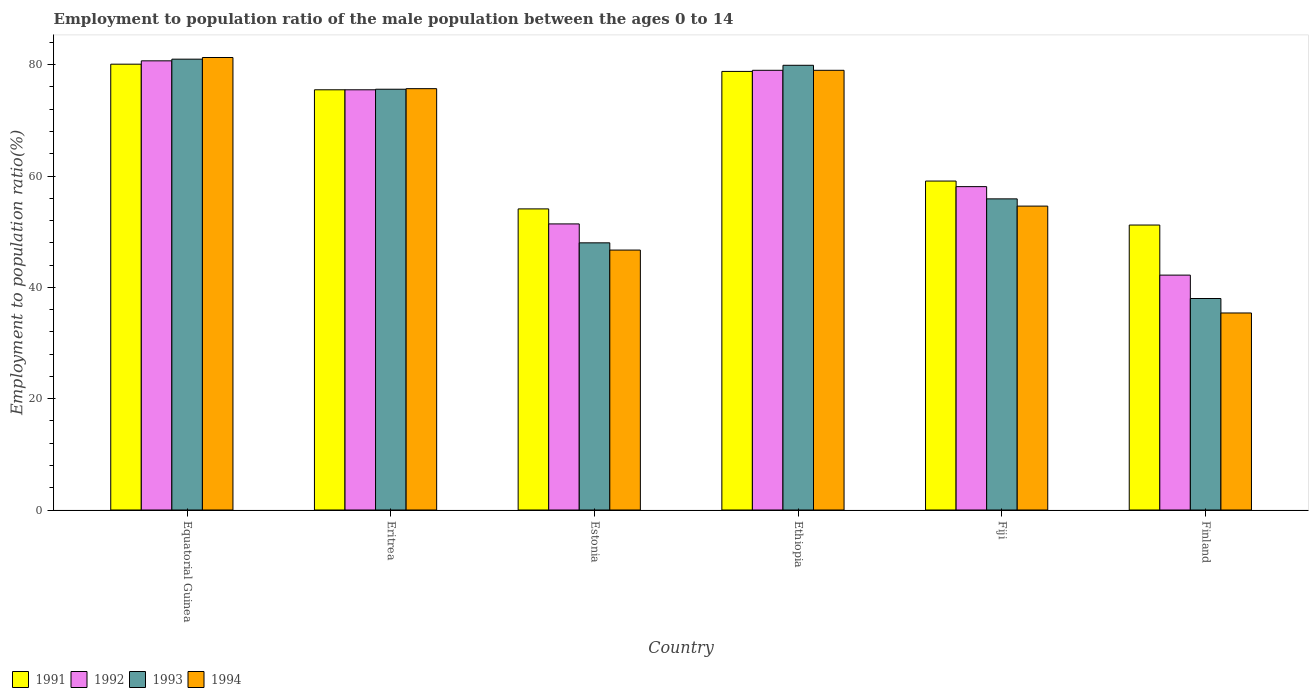How many different coloured bars are there?
Keep it short and to the point. 4. How many groups of bars are there?
Your answer should be compact. 6. Are the number of bars on each tick of the X-axis equal?
Offer a terse response. Yes. How many bars are there on the 1st tick from the left?
Provide a short and direct response. 4. What is the label of the 3rd group of bars from the left?
Keep it short and to the point. Estonia. What is the employment to population ratio in 1991 in Ethiopia?
Keep it short and to the point. 78.8. Across all countries, what is the maximum employment to population ratio in 1992?
Make the answer very short. 80.7. Across all countries, what is the minimum employment to population ratio in 1992?
Offer a very short reply. 42.2. In which country was the employment to population ratio in 1994 maximum?
Keep it short and to the point. Equatorial Guinea. In which country was the employment to population ratio in 1994 minimum?
Offer a very short reply. Finland. What is the total employment to population ratio in 1992 in the graph?
Keep it short and to the point. 386.9. What is the difference between the employment to population ratio in 1993 in Equatorial Guinea and that in Eritrea?
Keep it short and to the point. 5.4. What is the average employment to population ratio in 1993 per country?
Your answer should be very brief. 63.07. What is the difference between the employment to population ratio of/in 1991 and employment to population ratio of/in 1994 in Equatorial Guinea?
Give a very brief answer. -1.2. In how many countries, is the employment to population ratio in 1991 greater than 60 %?
Your answer should be very brief. 3. What is the ratio of the employment to population ratio in 1991 in Equatorial Guinea to that in Eritrea?
Offer a very short reply. 1.06. Is the difference between the employment to population ratio in 1991 in Eritrea and Finland greater than the difference between the employment to population ratio in 1994 in Eritrea and Finland?
Provide a succinct answer. No. What is the difference between the highest and the second highest employment to population ratio in 1993?
Offer a very short reply. 5.4. What is the difference between the highest and the lowest employment to population ratio in 1991?
Provide a succinct answer. 28.9. In how many countries, is the employment to population ratio in 1994 greater than the average employment to population ratio in 1994 taken over all countries?
Provide a succinct answer. 3. Is it the case that in every country, the sum of the employment to population ratio in 1992 and employment to population ratio in 1994 is greater than the sum of employment to population ratio in 1991 and employment to population ratio in 1993?
Make the answer very short. No. Is it the case that in every country, the sum of the employment to population ratio in 1992 and employment to population ratio in 1993 is greater than the employment to population ratio in 1994?
Provide a short and direct response. Yes. Does the graph contain any zero values?
Your answer should be compact. No. Does the graph contain grids?
Keep it short and to the point. No. Where does the legend appear in the graph?
Offer a terse response. Bottom left. What is the title of the graph?
Offer a terse response. Employment to population ratio of the male population between the ages 0 to 14. What is the Employment to population ratio(%) of 1991 in Equatorial Guinea?
Ensure brevity in your answer.  80.1. What is the Employment to population ratio(%) of 1992 in Equatorial Guinea?
Keep it short and to the point. 80.7. What is the Employment to population ratio(%) in 1994 in Equatorial Guinea?
Keep it short and to the point. 81.3. What is the Employment to population ratio(%) of 1991 in Eritrea?
Provide a short and direct response. 75.5. What is the Employment to population ratio(%) in 1992 in Eritrea?
Your answer should be very brief. 75.5. What is the Employment to population ratio(%) in 1993 in Eritrea?
Your answer should be compact. 75.6. What is the Employment to population ratio(%) in 1994 in Eritrea?
Make the answer very short. 75.7. What is the Employment to population ratio(%) of 1991 in Estonia?
Give a very brief answer. 54.1. What is the Employment to population ratio(%) of 1992 in Estonia?
Your response must be concise. 51.4. What is the Employment to population ratio(%) of 1994 in Estonia?
Your answer should be very brief. 46.7. What is the Employment to population ratio(%) in 1991 in Ethiopia?
Provide a short and direct response. 78.8. What is the Employment to population ratio(%) of 1992 in Ethiopia?
Your response must be concise. 79. What is the Employment to population ratio(%) in 1993 in Ethiopia?
Your answer should be very brief. 79.9. What is the Employment to population ratio(%) of 1994 in Ethiopia?
Keep it short and to the point. 79. What is the Employment to population ratio(%) of 1991 in Fiji?
Provide a short and direct response. 59.1. What is the Employment to population ratio(%) of 1992 in Fiji?
Your response must be concise. 58.1. What is the Employment to population ratio(%) in 1993 in Fiji?
Ensure brevity in your answer.  55.9. What is the Employment to population ratio(%) in 1994 in Fiji?
Ensure brevity in your answer.  54.6. What is the Employment to population ratio(%) in 1991 in Finland?
Make the answer very short. 51.2. What is the Employment to population ratio(%) in 1992 in Finland?
Offer a very short reply. 42.2. What is the Employment to population ratio(%) in 1994 in Finland?
Your answer should be compact. 35.4. Across all countries, what is the maximum Employment to population ratio(%) in 1991?
Provide a succinct answer. 80.1. Across all countries, what is the maximum Employment to population ratio(%) of 1992?
Keep it short and to the point. 80.7. Across all countries, what is the maximum Employment to population ratio(%) in 1993?
Your response must be concise. 81. Across all countries, what is the maximum Employment to population ratio(%) in 1994?
Offer a very short reply. 81.3. Across all countries, what is the minimum Employment to population ratio(%) in 1991?
Keep it short and to the point. 51.2. Across all countries, what is the minimum Employment to population ratio(%) of 1992?
Make the answer very short. 42.2. Across all countries, what is the minimum Employment to population ratio(%) in 1993?
Offer a terse response. 38. Across all countries, what is the minimum Employment to population ratio(%) of 1994?
Give a very brief answer. 35.4. What is the total Employment to population ratio(%) in 1991 in the graph?
Provide a short and direct response. 398.8. What is the total Employment to population ratio(%) in 1992 in the graph?
Give a very brief answer. 386.9. What is the total Employment to population ratio(%) of 1993 in the graph?
Provide a succinct answer. 378.4. What is the total Employment to population ratio(%) of 1994 in the graph?
Offer a terse response. 372.7. What is the difference between the Employment to population ratio(%) of 1992 in Equatorial Guinea and that in Eritrea?
Keep it short and to the point. 5.2. What is the difference between the Employment to population ratio(%) of 1992 in Equatorial Guinea and that in Estonia?
Offer a very short reply. 29.3. What is the difference between the Employment to population ratio(%) in 1993 in Equatorial Guinea and that in Estonia?
Make the answer very short. 33. What is the difference between the Employment to population ratio(%) of 1994 in Equatorial Guinea and that in Estonia?
Your response must be concise. 34.6. What is the difference between the Employment to population ratio(%) in 1992 in Equatorial Guinea and that in Fiji?
Provide a succinct answer. 22.6. What is the difference between the Employment to population ratio(%) in 1993 in Equatorial Guinea and that in Fiji?
Provide a short and direct response. 25.1. What is the difference between the Employment to population ratio(%) in 1994 in Equatorial Guinea and that in Fiji?
Keep it short and to the point. 26.7. What is the difference between the Employment to population ratio(%) of 1991 in Equatorial Guinea and that in Finland?
Give a very brief answer. 28.9. What is the difference between the Employment to population ratio(%) in 1992 in Equatorial Guinea and that in Finland?
Offer a very short reply. 38.5. What is the difference between the Employment to population ratio(%) of 1993 in Equatorial Guinea and that in Finland?
Give a very brief answer. 43. What is the difference between the Employment to population ratio(%) in 1994 in Equatorial Guinea and that in Finland?
Provide a succinct answer. 45.9. What is the difference between the Employment to population ratio(%) of 1991 in Eritrea and that in Estonia?
Offer a very short reply. 21.4. What is the difference between the Employment to population ratio(%) of 1992 in Eritrea and that in Estonia?
Offer a terse response. 24.1. What is the difference between the Employment to population ratio(%) of 1993 in Eritrea and that in Estonia?
Ensure brevity in your answer.  27.6. What is the difference between the Employment to population ratio(%) in 1992 in Eritrea and that in Ethiopia?
Provide a succinct answer. -3.5. What is the difference between the Employment to population ratio(%) of 1993 in Eritrea and that in Ethiopia?
Keep it short and to the point. -4.3. What is the difference between the Employment to population ratio(%) in 1994 in Eritrea and that in Ethiopia?
Offer a terse response. -3.3. What is the difference between the Employment to population ratio(%) of 1991 in Eritrea and that in Fiji?
Offer a terse response. 16.4. What is the difference between the Employment to population ratio(%) of 1994 in Eritrea and that in Fiji?
Make the answer very short. 21.1. What is the difference between the Employment to population ratio(%) of 1991 in Eritrea and that in Finland?
Your answer should be very brief. 24.3. What is the difference between the Employment to population ratio(%) in 1992 in Eritrea and that in Finland?
Make the answer very short. 33.3. What is the difference between the Employment to population ratio(%) in 1993 in Eritrea and that in Finland?
Your answer should be very brief. 37.6. What is the difference between the Employment to population ratio(%) of 1994 in Eritrea and that in Finland?
Provide a succinct answer. 40.3. What is the difference between the Employment to population ratio(%) of 1991 in Estonia and that in Ethiopia?
Provide a succinct answer. -24.7. What is the difference between the Employment to population ratio(%) of 1992 in Estonia and that in Ethiopia?
Give a very brief answer. -27.6. What is the difference between the Employment to population ratio(%) in 1993 in Estonia and that in Ethiopia?
Your response must be concise. -31.9. What is the difference between the Employment to population ratio(%) of 1994 in Estonia and that in Ethiopia?
Offer a terse response. -32.3. What is the difference between the Employment to population ratio(%) of 1991 in Estonia and that in Fiji?
Make the answer very short. -5. What is the difference between the Employment to population ratio(%) in 1992 in Estonia and that in Fiji?
Give a very brief answer. -6.7. What is the difference between the Employment to population ratio(%) of 1993 in Estonia and that in Fiji?
Provide a short and direct response. -7.9. What is the difference between the Employment to population ratio(%) of 1994 in Estonia and that in Fiji?
Provide a short and direct response. -7.9. What is the difference between the Employment to population ratio(%) in 1992 in Estonia and that in Finland?
Make the answer very short. 9.2. What is the difference between the Employment to population ratio(%) of 1994 in Estonia and that in Finland?
Offer a terse response. 11.3. What is the difference between the Employment to population ratio(%) in 1991 in Ethiopia and that in Fiji?
Give a very brief answer. 19.7. What is the difference between the Employment to population ratio(%) of 1992 in Ethiopia and that in Fiji?
Your response must be concise. 20.9. What is the difference between the Employment to population ratio(%) in 1994 in Ethiopia and that in Fiji?
Provide a short and direct response. 24.4. What is the difference between the Employment to population ratio(%) of 1991 in Ethiopia and that in Finland?
Provide a short and direct response. 27.6. What is the difference between the Employment to population ratio(%) of 1992 in Ethiopia and that in Finland?
Your response must be concise. 36.8. What is the difference between the Employment to population ratio(%) of 1993 in Ethiopia and that in Finland?
Offer a terse response. 41.9. What is the difference between the Employment to population ratio(%) in 1994 in Ethiopia and that in Finland?
Make the answer very short. 43.6. What is the difference between the Employment to population ratio(%) of 1993 in Fiji and that in Finland?
Your response must be concise. 17.9. What is the difference between the Employment to population ratio(%) of 1994 in Fiji and that in Finland?
Your answer should be compact. 19.2. What is the difference between the Employment to population ratio(%) of 1992 in Equatorial Guinea and the Employment to population ratio(%) of 1993 in Eritrea?
Your answer should be compact. 5.1. What is the difference between the Employment to population ratio(%) of 1991 in Equatorial Guinea and the Employment to population ratio(%) of 1992 in Estonia?
Offer a terse response. 28.7. What is the difference between the Employment to population ratio(%) in 1991 in Equatorial Guinea and the Employment to population ratio(%) in 1993 in Estonia?
Your answer should be very brief. 32.1. What is the difference between the Employment to population ratio(%) of 1991 in Equatorial Guinea and the Employment to population ratio(%) of 1994 in Estonia?
Offer a very short reply. 33.4. What is the difference between the Employment to population ratio(%) in 1992 in Equatorial Guinea and the Employment to population ratio(%) in 1993 in Estonia?
Your response must be concise. 32.7. What is the difference between the Employment to population ratio(%) of 1993 in Equatorial Guinea and the Employment to population ratio(%) of 1994 in Estonia?
Your response must be concise. 34.3. What is the difference between the Employment to population ratio(%) of 1991 in Equatorial Guinea and the Employment to population ratio(%) of 1994 in Ethiopia?
Make the answer very short. 1.1. What is the difference between the Employment to population ratio(%) of 1992 in Equatorial Guinea and the Employment to population ratio(%) of 1993 in Ethiopia?
Provide a succinct answer. 0.8. What is the difference between the Employment to population ratio(%) in 1992 in Equatorial Guinea and the Employment to population ratio(%) in 1994 in Ethiopia?
Your response must be concise. 1.7. What is the difference between the Employment to population ratio(%) of 1993 in Equatorial Guinea and the Employment to population ratio(%) of 1994 in Ethiopia?
Give a very brief answer. 2. What is the difference between the Employment to population ratio(%) of 1991 in Equatorial Guinea and the Employment to population ratio(%) of 1993 in Fiji?
Your response must be concise. 24.2. What is the difference between the Employment to population ratio(%) in 1991 in Equatorial Guinea and the Employment to population ratio(%) in 1994 in Fiji?
Provide a succinct answer. 25.5. What is the difference between the Employment to population ratio(%) in 1992 in Equatorial Guinea and the Employment to population ratio(%) in 1993 in Fiji?
Provide a succinct answer. 24.8. What is the difference between the Employment to population ratio(%) in 1992 in Equatorial Guinea and the Employment to population ratio(%) in 1994 in Fiji?
Provide a succinct answer. 26.1. What is the difference between the Employment to population ratio(%) in 1993 in Equatorial Guinea and the Employment to population ratio(%) in 1994 in Fiji?
Provide a succinct answer. 26.4. What is the difference between the Employment to population ratio(%) in 1991 in Equatorial Guinea and the Employment to population ratio(%) in 1992 in Finland?
Provide a succinct answer. 37.9. What is the difference between the Employment to population ratio(%) of 1991 in Equatorial Guinea and the Employment to population ratio(%) of 1993 in Finland?
Your answer should be compact. 42.1. What is the difference between the Employment to population ratio(%) in 1991 in Equatorial Guinea and the Employment to population ratio(%) in 1994 in Finland?
Offer a very short reply. 44.7. What is the difference between the Employment to population ratio(%) in 1992 in Equatorial Guinea and the Employment to population ratio(%) in 1993 in Finland?
Your answer should be very brief. 42.7. What is the difference between the Employment to population ratio(%) of 1992 in Equatorial Guinea and the Employment to population ratio(%) of 1994 in Finland?
Offer a very short reply. 45.3. What is the difference between the Employment to population ratio(%) of 1993 in Equatorial Guinea and the Employment to population ratio(%) of 1994 in Finland?
Offer a terse response. 45.6. What is the difference between the Employment to population ratio(%) of 1991 in Eritrea and the Employment to population ratio(%) of 1992 in Estonia?
Your answer should be very brief. 24.1. What is the difference between the Employment to population ratio(%) in 1991 in Eritrea and the Employment to population ratio(%) in 1993 in Estonia?
Provide a short and direct response. 27.5. What is the difference between the Employment to population ratio(%) in 1991 in Eritrea and the Employment to population ratio(%) in 1994 in Estonia?
Give a very brief answer. 28.8. What is the difference between the Employment to population ratio(%) of 1992 in Eritrea and the Employment to population ratio(%) of 1994 in Estonia?
Ensure brevity in your answer.  28.8. What is the difference between the Employment to population ratio(%) of 1993 in Eritrea and the Employment to population ratio(%) of 1994 in Estonia?
Your answer should be compact. 28.9. What is the difference between the Employment to population ratio(%) in 1991 in Eritrea and the Employment to population ratio(%) in 1994 in Ethiopia?
Provide a succinct answer. -3.5. What is the difference between the Employment to population ratio(%) in 1993 in Eritrea and the Employment to population ratio(%) in 1994 in Ethiopia?
Offer a very short reply. -3.4. What is the difference between the Employment to population ratio(%) of 1991 in Eritrea and the Employment to population ratio(%) of 1993 in Fiji?
Your answer should be very brief. 19.6. What is the difference between the Employment to population ratio(%) in 1991 in Eritrea and the Employment to population ratio(%) in 1994 in Fiji?
Make the answer very short. 20.9. What is the difference between the Employment to population ratio(%) in 1992 in Eritrea and the Employment to population ratio(%) in 1993 in Fiji?
Your answer should be very brief. 19.6. What is the difference between the Employment to population ratio(%) in 1992 in Eritrea and the Employment to population ratio(%) in 1994 in Fiji?
Offer a terse response. 20.9. What is the difference between the Employment to population ratio(%) of 1991 in Eritrea and the Employment to population ratio(%) of 1992 in Finland?
Ensure brevity in your answer.  33.3. What is the difference between the Employment to population ratio(%) of 1991 in Eritrea and the Employment to population ratio(%) of 1993 in Finland?
Provide a short and direct response. 37.5. What is the difference between the Employment to population ratio(%) of 1991 in Eritrea and the Employment to population ratio(%) of 1994 in Finland?
Provide a short and direct response. 40.1. What is the difference between the Employment to population ratio(%) in 1992 in Eritrea and the Employment to population ratio(%) in 1993 in Finland?
Ensure brevity in your answer.  37.5. What is the difference between the Employment to population ratio(%) of 1992 in Eritrea and the Employment to population ratio(%) of 1994 in Finland?
Make the answer very short. 40.1. What is the difference between the Employment to population ratio(%) of 1993 in Eritrea and the Employment to population ratio(%) of 1994 in Finland?
Your answer should be compact. 40.2. What is the difference between the Employment to population ratio(%) of 1991 in Estonia and the Employment to population ratio(%) of 1992 in Ethiopia?
Offer a terse response. -24.9. What is the difference between the Employment to population ratio(%) of 1991 in Estonia and the Employment to population ratio(%) of 1993 in Ethiopia?
Give a very brief answer. -25.8. What is the difference between the Employment to population ratio(%) in 1991 in Estonia and the Employment to population ratio(%) in 1994 in Ethiopia?
Your answer should be compact. -24.9. What is the difference between the Employment to population ratio(%) of 1992 in Estonia and the Employment to population ratio(%) of 1993 in Ethiopia?
Offer a very short reply. -28.5. What is the difference between the Employment to population ratio(%) in 1992 in Estonia and the Employment to population ratio(%) in 1994 in Ethiopia?
Offer a terse response. -27.6. What is the difference between the Employment to population ratio(%) of 1993 in Estonia and the Employment to population ratio(%) of 1994 in Ethiopia?
Your answer should be compact. -31. What is the difference between the Employment to population ratio(%) in 1991 in Estonia and the Employment to population ratio(%) in 1992 in Fiji?
Provide a short and direct response. -4. What is the difference between the Employment to population ratio(%) of 1991 in Estonia and the Employment to population ratio(%) of 1994 in Fiji?
Your answer should be very brief. -0.5. What is the difference between the Employment to population ratio(%) of 1992 in Estonia and the Employment to population ratio(%) of 1993 in Fiji?
Your answer should be very brief. -4.5. What is the difference between the Employment to population ratio(%) in 1992 in Estonia and the Employment to population ratio(%) in 1994 in Fiji?
Your answer should be very brief. -3.2. What is the difference between the Employment to population ratio(%) in 1991 in Estonia and the Employment to population ratio(%) in 1992 in Finland?
Your answer should be compact. 11.9. What is the difference between the Employment to population ratio(%) of 1991 in Estonia and the Employment to population ratio(%) of 1994 in Finland?
Make the answer very short. 18.7. What is the difference between the Employment to population ratio(%) in 1992 in Estonia and the Employment to population ratio(%) in 1993 in Finland?
Ensure brevity in your answer.  13.4. What is the difference between the Employment to population ratio(%) of 1993 in Estonia and the Employment to population ratio(%) of 1994 in Finland?
Offer a terse response. 12.6. What is the difference between the Employment to population ratio(%) in 1991 in Ethiopia and the Employment to population ratio(%) in 1992 in Fiji?
Ensure brevity in your answer.  20.7. What is the difference between the Employment to population ratio(%) in 1991 in Ethiopia and the Employment to population ratio(%) in 1993 in Fiji?
Make the answer very short. 22.9. What is the difference between the Employment to population ratio(%) in 1991 in Ethiopia and the Employment to population ratio(%) in 1994 in Fiji?
Provide a short and direct response. 24.2. What is the difference between the Employment to population ratio(%) of 1992 in Ethiopia and the Employment to population ratio(%) of 1993 in Fiji?
Provide a short and direct response. 23.1. What is the difference between the Employment to population ratio(%) of 1992 in Ethiopia and the Employment to population ratio(%) of 1994 in Fiji?
Your answer should be compact. 24.4. What is the difference between the Employment to population ratio(%) in 1993 in Ethiopia and the Employment to population ratio(%) in 1994 in Fiji?
Make the answer very short. 25.3. What is the difference between the Employment to population ratio(%) in 1991 in Ethiopia and the Employment to population ratio(%) in 1992 in Finland?
Offer a terse response. 36.6. What is the difference between the Employment to population ratio(%) of 1991 in Ethiopia and the Employment to population ratio(%) of 1993 in Finland?
Your answer should be compact. 40.8. What is the difference between the Employment to population ratio(%) of 1991 in Ethiopia and the Employment to population ratio(%) of 1994 in Finland?
Ensure brevity in your answer.  43.4. What is the difference between the Employment to population ratio(%) in 1992 in Ethiopia and the Employment to population ratio(%) in 1994 in Finland?
Your response must be concise. 43.6. What is the difference between the Employment to population ratio(%) of 1993 in Ethiopia and the Employment to population ratio(%) of 1994 in Finland?
Offer a terse response. 44.5. What is the difference between the Employment to population ratio(%) of 1991 in Fiji and the Employment to population ratio(%) of 1993 in Finland?
Ensure brevity in your answer.  21.1. What is the difference between the Employment to population ratio(%) in 1991 in Fiji and the Employment to population ratio(%) in 1994 in Finland?
Ensure brevity in your answer.  23.7. What is the difference between the Employment to population ratio(%) in 1992 in Fiji and the Employment to population ratio(%) in 1993 in Finland?
Keep it short and to the point. 20.1. What is the difference between the Employment to population ratio(%) in 1992 in Fiji and the Employment to population ratio(%) in 1994 in Finland?
Give a very brief answer. 22.7. What is the difference between the Employment to population ratio(%) in 1993 in Fiji and the Employment to population ratio(%) in 1994 in Finland?
Keep it short and to the point. 20.5. What is the average Employment to population ratio(%) of 1991 per country?
Keep it short and to the point. 66.47. What is the average Employment to population ratio(%) in 1992 per country?
Give a very brief answer. 64.48. What is the average Employment to population ratio(%) of 1993 per country?
Provide a short and direct response. 63.07. What is the average Employment to population ratio(%) in 1994 per country?
Your response must be concise. 62.12. What is the difference between the Employment to population ratio(%) of 1991 and Employment to population ratio(%) of 1992 in Equatorial Guinea?
Offer a terse response. -0.6. What is the difference between the Employment to population ratio(%) in 1991 and Employment to population ratio(%) in 1993 in Equatorial Guinea?
Keep it short and to the point. -0.9. What is the difference between the Employment to population ratio(%) in 1991 and Employment to population ratio(%) in 1994 in Equatorial Guinea?
Offer a terse response. -1.2. What is the difference between the Employment to population ratio(%) of 1992 and Employment to population ratio(%) of 1993 in Equatorial Guinea?
Offer a very short reply. -0.3. What is the difference between the Employment to population ratio(%) of 1992 and Employment to population ratio(%) of 1993 in Eritrea?
Your response must be concise. -0.1. What is the difference between the Employment to population ratio(%) of 1993 and Employment to population ratio(%) of 1994 in Eritrea?
Ensure brevity in your answer.  -0.1. What is the difference between the Employment to population ratio(%) of 1991 and Employment to population ratio(%) of 1992 in Estonia?
Offer a very short reply. 2.7. What is the difference between the Employment to population ratio(%) in 1991 and Employment to population ratio(%) in 1993 in Estonia?
Ensure brevity in your answer.  6.1. What is the difference between the Employment to population ratio(%) of 1991 and Employment to population ratio(%) of 1994 in Estonia?
Make the answer very short. 7.4. What is the difference between the Employment to population ratio(%) of 1992 and Employment to population ratio(%) of 1994 in Estonia?
Ensure brevity in your answer.  4.7. What is the difference between the Employment to population ratio(%) in 1991 and Employment to population ratio(%) in 1993 in Ethiopia?
Your response must be concise. -1.1. What is the difference between the Employment to population ratio(%) in 1992 and Employment to population ratio(%) in 1993 in Ethiopia?
Offer a terse response. -0.9. What is the difference between the Employment to population ratio(%) of 1991 and Employment to population ratio(%) of 1992 in Fiji?
Give a very brief answer. 1. What is the difference between the Employment to population ratio(%) in 1991 and Employment to population ratio(%) in 1993 in Fiji?
Offer a very short reply. 3.2. What is the difference between the Employment to population ratio(%) of 1991 and Employment to population ratio(%) of 1994 in Fiji?
Your answer should be very brief. 4.5. What is the difference between the Employment to population ratio(%) of 1991 and Employment to population ratio(%) of 1993 in Finland?
Give a very brief answer. 13.2. What is the difference between the Employment to population ratio(%) of 1992 and Employment to population ratio(%) of 1994 in Finland?
Your response must be concise. 6.8. What is the ratio of the Employment to population ratio(%) of 1991 in Equatorial Guinea to that in Eritrea?
Offer a terse response. 1.06. What is the ratio of the Employment to population ratio(%) in 1992 in Equatorial Guinea to that in Eritrea?
Your response must be concise. 1.07. What is the ratio of the Employment to population ratio(%) in 1993 in Equatorial Guinea to that in Eritrea?
Provide a short and direct response. 1.07. What is the ratio of the Employment to population ratio(%) of 1994 in Equatorial Guinea to that in Eritrea?
Provide a short and direct response. 1.07. What is the ratio of the Employment to population ratio(%) in 1991 in Equatorial Guinea to that in Estonia?
Give a very brief answer. 1.48. What is the ratio of the Employment to population ratio(%) in 1992 in Equatorial Guinea to that in Estonia?
Provide a succinct answer. 1.57. What is the ratio of the Employment to population ratio(%) of 1993 in Equatorial Guinea to that in Estonia?
Provide a short and direct response. 1.69. What is the ratio of the Employment to population ratio(%) in 1994 in Equatorial Guinea to that in Estonia?
Provide a succinct answer. 1.74. What is the ratio of the Employment to population ratio(%) in 1991 in Equatorial Guinea to that in Ethiopia?
Give a very brief answer. 1.02. What is the ratio of the Employment to population ratio(%) in 1992 in Equatorial Guinea to that in Ethiopia?
Your response must be concise. 1.02. What is the ratio of the Employment to population ratio(%) in 1993 in Equatorial Guinea to that in Ethiopia?
Provide a succinct answer. 1.01. What is the ratio of the Employment to population ratio(%) in 1994 in Equatorial Guinea to that in Ethiopia?
Your answer should be very brief. 1.03. What is the ratio of the Employment to population ratio(%) of 1991 in Equatorial Guinea to that in Fiji?
Provide a succinct answer. 1.36. What is the ratio of the Employment to population ratio(%) in 1992 in Equatorial Guinea to that in Fiji?
Offer a terse response. 1.39. What is the ratio of the Employment to population ratio(%) of 1993 in Equatorial Guinea to that in Fiji?
Ensure brevity in your answer.  1.45. What is the ratio of the Employment to population ratio(%) of 1994 in Equatorial Guinea to that in Fiji?
Provide a succinct answer. 1.49. What is the ratio of the Employment to population ratio(%) of 1991 in Equatorial Guinea to that in Finland?
Provide a short and direct response. 1.56. What is the ratio of the Employment to population ratio(%) in 1992 in Equatorial Guinea to that in Finland?
Your answer should be very brief. 1.91. What is the ratio of the Employment to population ratio(%) of 1993 in Equatorial Guinea to that in Finland?
Offer a very short reply. 2.13. What is the ratio of the Employment to population ratio(%) of 1994 in Equatorial Guinea to that in Finland?
Keep it short and to the point. 2.3. What is the ratio of the Employment to population ratio(%) of 1991 in Eritrea to that in Estonia?
Make the answer very short. 1.4. What is the ratio of the Employment to population ratio(%) of 1992 in Eritrea to that in Estonia?
Make the answer very short. 1.47. What is the ratio of the Employment to population ratio(%) in 1993 in Eritrea to that in Estonia?
Make the answer very short. 1.57. What is the ratio of the Employment to population ratio(%) in 1994 in Eritrea to that in Estonia?
Your answer should be very brief. 1.62. What is the ratio of the Employment to population ratio(%) of 1991 in Eritrea to that in Ethiopia?
Make the answer very short. 0.96. What is the ratio of the Employment to population ratio(%) of 1992 in Eritrea to that in Ethiopia?
Give a very brief answer. 0.96. What is the ratio of the Employment to population ratio(%) of 1993 in Eritrea to that in Ethiopia?
Ensure brevity in your answer.  0.95. What is the ratio of the Employment to population ratio(%) in 1994 in Eritrea to that in Ethiopia?
Provide a succinct answer. 0.96. What is the ratio of the Employment to population ratio(%) of 1991 in Eritrea to that in Fiji?
Your answer should be very brief. 1.28. What is the ratio of the Employment to population ratio(%) of 1992 in Eritrea to that in Fiji?
Provide a succinct answer. 1.3. What is the ratio of the Employment to population ratio(%) in 1993 in Eritrea to that in Fiji?
Your answer should be very brief. 1.35. What is the ratio of the Employment to population ratio(%) of 1994 in Eritrea to that in Fiji?
Make the answer very short. 1.39. What is the ratio of the Employment to population ratio(%) of 1991 in Eritrea to that in Finland?
Your response must be concise. 1.47. What is the ratio of the Employment to population ratio(%) in 1992 in Eritrea to that in Finland?
Your answer should be very brief. 1.79. What is the ratio of the Employment to population ratio(%) of 1993 in Eritrea to that in Finland?
Make the answer very short. 1.99. What is the ratio of the Employment to population ratio(%) of 1994 in Eritrea to that in Finland?
Offer a terse response. 2.14. What is the ratio of the Employment to population ratio(%) of 1991 in Estonia to that in Ethiopia?
Make the answer very short. 0.69. What is the ratio of the Employment to population ratio(%) of 1992 in Estonia to that in Ethiopia?
Ensure brevity in your answer.  0.65. What is the ratio of the Employment to population ratio(%) in 1993 in Estonia to that in Ethiopia?
Offer a terse response. 0.6. What is the ratio of the Employment to population ratio(%) of 1994 in Estonia to that in Ethiopia?
Offer a terse response. 0.59. What is the ratio of the Employment to population ratio(%) of 1991 in Estonia to that in Fiji?
Provide a short and direct response. 0.92. What is the ratio of the Employment to population ratio(%) in 1992 in Estonia to that in Fiji?
Provide a succinct answer. 0.88. What is the ratio of the Employment to population ratio(%) of 1993 in Estonia to that in Fiji?
Your answer should be compact. 0.86. What is the ratio of the Employment to population ratio(%) of 1994 in Estonia to that in Fiji?
Ensure brevity in your answer.  0.86. What is the ratio of the Employment to population ratio(%) of 1991 in Estonia to that in Finland?
Provide a short and direct response. 1.06. What is the ratio of the Employment to population ratio(%) in 1992 in Estonia to that in Finland?
Your response must be concise. 1.22. What is the ratio of the Employment to population ratio(%) of 1993 in Estonia to that in Finland?
Your answer should be compact. 1.26. What is the ratio of the Employment to population ratio(%) of 1994 in Estonia to that in Finland?
Keep it short and to the point. 1.32. What is the ratio of the Employment to population ratio(%) in 1991 in Ethiopia to that in Fiji?
Your answer should be compact. 1.33. What is the ratio of the Employment to population ratio(%) in 1992 in Ethiopia to that in Fiji?
Your answer should be very brief. 1.36. What is the ratio of the Employment to population ratio(%) in 1993 in Ethiopia to that in Fiji?
Ensure brevity in your answer.  1.43. What is the ratio of the Employment to population ratio(%) in 1994 in Ethiopia to that in Fiji?
Your response must be concise. 1.45. What is the ratio of the Employment to population ratio(%) in 1991 in Ethiopia to that in Finland?
Provide a short and direct response. 1.54. What is the ratio of the Employment to population ratio(%) of 1992 in Ethiopia to that in Finland?
Make the answer very short. 1.87. What is the ratio of the Employment to population ratio(%) in 1993 in Ethiopia to that in Finland?
Your response must be concise. 2.1. What is the ratio of the Employment to population ratio(%) of 1994 in Ethiopia to that in Finland?
Give a very brief answer. 2.23. What is the ratio of the Employment to population ratio(%) in 1991 in Fiji to that in Finland?
Keep it short and to the point. 1.15. What is the ratio of the Employment to population ratio(%) in 1992 in Fiji to that in Finland?
Provide a short and direct response. 1.38. What is the ratio of the Employment to population ratio(%) of 1993 in Fiji to that in Finland?
Your answer should be very brief. 1.47. What is the ratio of the Employment to population ratio(%) in 1994 in Fiji to that in Finland?
Your answer should be compact. 1.54. What is the difference between the highest and the second highest Employment to population ratio(%) in 1992?
Ensure brevity in your answer.  1.7. What is the difference between the highest and the second highest Employment to population ratio(%) of 1993?
Offer a terse response. 1.1. What is the difference between the highest and the second highest Employment to population ratio(%) of 1994?
Ensure brevity in your answer.  2.3. What is the difference between the highest and the lowest Employment to population ratio(%) of 1991?
Keep it short and to the point. 28.9. What is the difference between the highest and the lowest Employment to population ratio(%) in 1992?
Provide a succinct answer. 38.5. What is the difference between the highest and the lowest Employment to population ratio(%) of 1993?
Your answer should be very brief. 43. What is the difference between the highest and the lowest Employment to population ratio(%) of 1994?
Your answer should be compact. 45.9. 